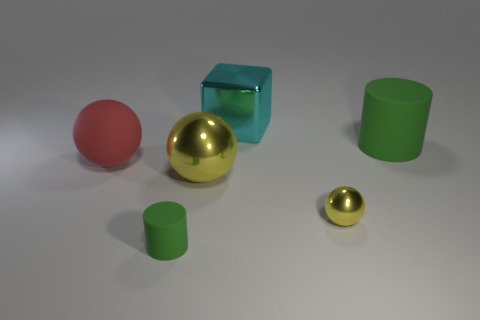Subtract 1 balls. How many balls are left? 2 Add 3 blue balls. How many objects exist? 9 Subtract all cylinders. How many objects are left? 4 Add 4 cyan cubes. How many cyan cubes are left? 5 Add 5 shiny things. How many shiny things exist? 8 Subtract 0 green spheres. How many objects are left? 6 Subtract all large green matte cylinders. Subtract all large cyan things. How many objects are left? 4 